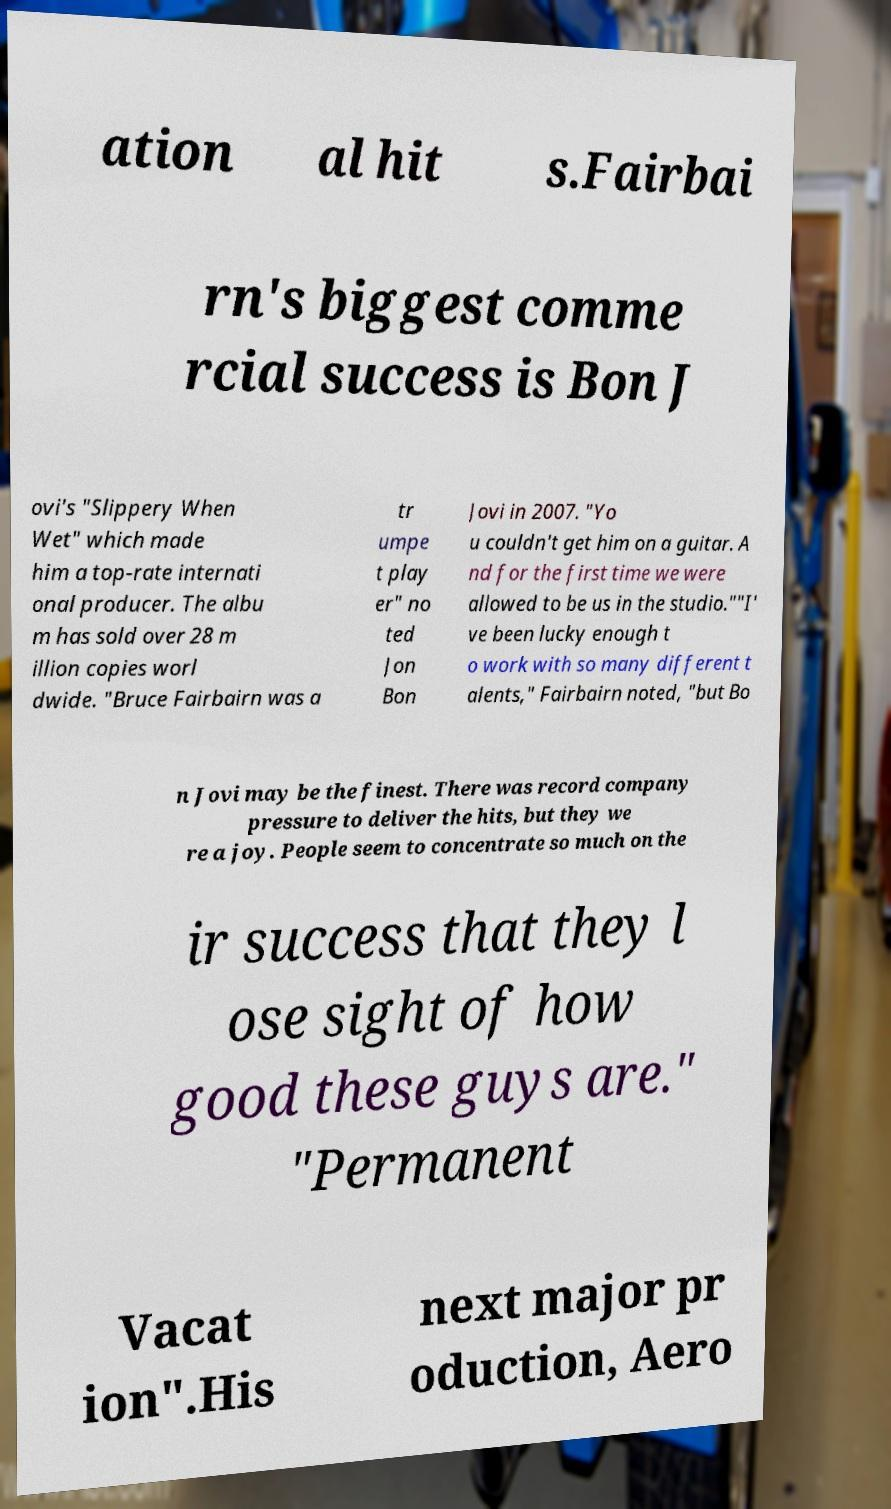For documentation purposes, I need the text within this image transcribed. Could you provide that? ation al hit s.Fairbai rn's biggest comme rcial success is Bon J ovi's "Slippery When Wet" which made him a top-rate internati onal producer. The albu m has sold over 28 m illion copies worl dwide. "Bruce Fairbairn was a tr umpe t play er" no ted Jon Bon Jovi in 2007. "Yo u couldn't get him on a guitar. A nd for the first time we were allowed to be us in the studio.""I' ve been lucky enough t o work with so many different t alents," Fairbairn noted, "but Bo n Jovi may be the finest. There was record company pressure to deliver the hits, but they we re a joy. People seem to concentrate so much on the ir success that they l ose sight of how good these guys are." "Permanent Vacat ion".His next major pr oduction, Aero 